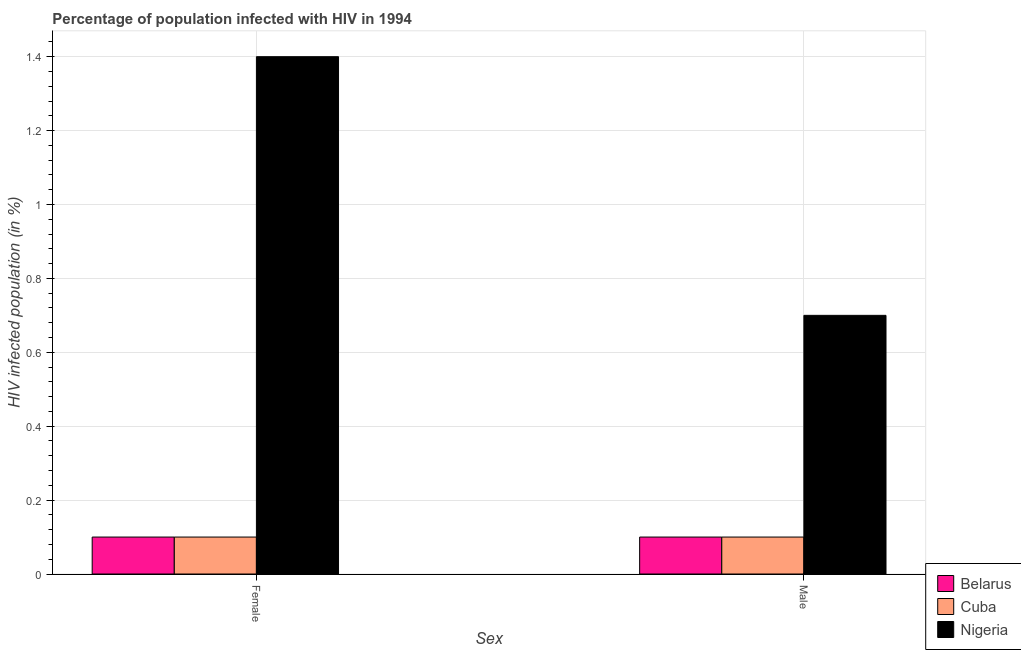How many different coloured bars are there?
Keep it short and to the point. 3. How many groups of bars are there?
Provide a succinct answer. 2. Are the number of bars per tick equal to the number of legend labels?
Your answer should be compact. Yes. How many bars are there on the 1st tick from the right?
Provide a short and direct response. 3. What is the label of the 2nd group of bars from the left?
Your response must be concise. Male. What is the percentage of females who are infected with hiv in Cuba?
Your response must be concise. 0.1. Across all countries, what is the maximum percentage of males who are infected with hiv?
Your answer should be compact. 0.7. Across all countries, what is the minimum percentage of males who are infected with hiv?
Your response must be concise. 0.1. In which country was the percentage of females who are infected with hiv maximum?
Your answer should be very brief. Nigeria. In which country was the percentage of females who are infected with hiv minimum?
Your response must be concise. Belarus. What is the total percentage of males who are infected with hiv in the graph?
Offer a terse response. 0.9. What is the difference between the percentage of females who are infected with hiv in Nigeria and the percentage of males who are infected with hiv in Cuba?
Keep it short and to the point. 1.3. What is the average percentage of females who are infected with hiv per country?
Give a very brief answer. 0.53. In how many countries, is the percentage of males who are infected with hiv greater than 0.28 %?
Your answer should be compact. 1. What is the ratio of the percentage of females who are infected with hiv in Belarus to that in Nigeria?
Give a very brief answer. 0.07. In how many countries, is the percentage of females who are infected with hiv greater than the average percentage of females who are infected with hiv taken over all countries?
Keep it short and to the point. 1. What does the 2nd bar from the left in Male represents?
Make the answer very short. Cuba. What does the 2nd bar from the right in Male represents?
Make the answer very short. Cuba. How many bars are there?
Provide a succinct answer. 6. How many countries are there in the graph?
Offer a very short reply. 3. What is the difference between two consecutive major ticks on the Y-axis?
Your answer should be compact. 0.2. Does the graph contain any zero values?
Provide a succinct answer. No. How many legend labels are there?
Give a very brief answer. 3. What is the title of the graph?
Offer a very short reply. Percentage of population infected with HIV in 1994. Does "Mali" appear as one of the legend labels in the graph?
Offer a terse response. No. What is the label or title of the X-axis?
Provide a short and direct response. Sex. What is the label or title of the Y-axis?
Ensure brevity in your answer.  HIV infected population (in %). What is the HIV infected population (in %) of Belarus in Female?
Provide a short and direct response. 0.1. What is the HIV infected population (in %) of Cuba in Male?
Keep it short and to the point. 0.1. What is the HIV infected population (in %) in Nigeria in Male?
Offer a terse response. 0.7. Across all Sex, what is the maximum HIV infected population (in %) in Belarus?
Offer a very short reply. 0.1. Across all Sex, what is the maximum HIV infected population (in %) of Cuba?
Your answer should be compact. 0.1. Across all Sex, what is the minimum HIV infected population (in %) in Belarus?
Offer a very short reply. 0.1. Across all Sex, what is the minimum HIV infected population (in %) of Cuba?
Your answer should be very brief. 0.1. Across all Sex, what is the minimum HIV infected population (in %) of Nigeria?
Make the answer very short. 0.7. What is the total HIV infected population (in %) in Cuba in the graph?
Give a very brief answer. 0.2. What is the total HIV infected population (in %) of Nigeria in the graph?
Ensure brevity in your answer.  2.1. What is the difference between the HIV infected population (in %) of Belarus in Female and that in Male?
Your answer should be compact. 0. What is the difference between the HIV infected population (in %) of Cuba in Female and that in Male?
Your response must be concise. 0. What is the difference between the HIV infected population (in %) in Belarus in Female and the HIV infected population (in %) in Nigeria in Male?
Your answer should be compact. -0.6. What is the difference between the HIV infected population (in %) in Belarus and HIV infected population (in %) in Nigeria in Female?
Offer a terse response. -1.3. What is the difference between the HIV infected population (in %) in Cuba and HIV infected population (in %) in Nigeria in Female?
Make the answer very short. -1.3. What is the difference between the HIV infected population (in %) of Belarus and HIV infected population (in %) of Nigeria in Male?
Offer a very short reply. -0.6. What is the difference between the HIV infected population (in %) in Cuba and HIV infected population (in %) in Nigeria in Male?
Make the answer very short. -0.6. What is the ratio of the HIV infected population (in %) of Nigeria in Female to that in Male?
Offer a terse response. 2. What is the difference between the highest and the second highest HIV infected population (in %) in Belarus?
Provide a short and direct response. 0. What is the difference between the highest and the second highest HIV infected population (in %) of Cuba?
Keep it short and to the point. 0. What is the difference between the highest and the second highest HIV infected population (in %) in Nigeria?
Ensure brevity in your answer.  0.7. What is the difference between the highest and the lowest HIV infected population (in %) of Belarus?
Keep it short and to the point. 0. What is the difference between the highest and the lowest HIV infected population (in %) of Cuba?
Your answer should be compact. 0. What is the difference between the highest and the lowest HIV infected population (in %) of Nigeria?
Make the answer very short. 0.7. 